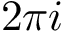<formula> <loc_0><loc_0><loc_500><loc_500>2 \pi i</formula> 